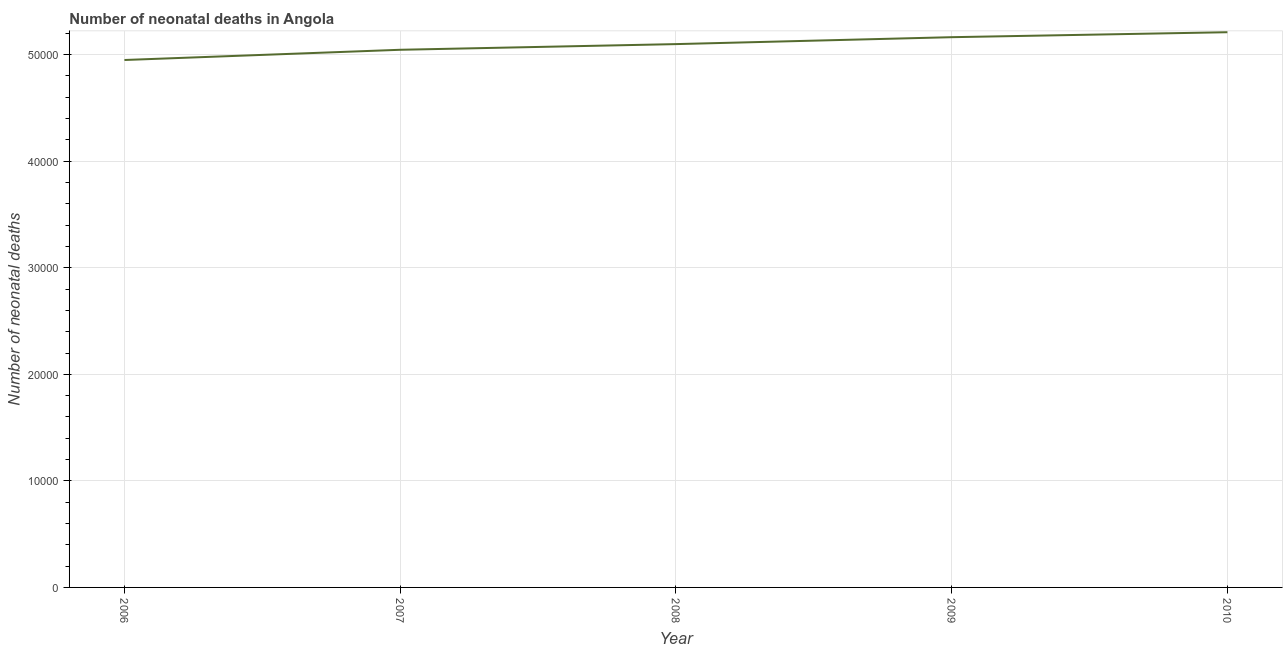What is the number of neonatal deaths in 2006?
Make the answer very short. 4.95e+04. Across all years, what is the maximum number of neonatal deaths?
Keep it short and to the point. 5.21e+04. Across all years, what is the minimum number of neonatal deaths?
Make the answer very short. 4.95e+04. In which year was the number of neonatal deaths minimum?
Your response must be concise. 2006. What is the sum of the number of neonatal deaths?
Your response must be concise. 2.55e+05. What is the difference between the number of neonatal deaths in 2006 and 2010?
Ensure brevity in your answer.  -2608. What is the average number of neonatal deaths per year?
Offer a terse response. 5.09e+04. What is the median number of neonatal deaths?
Provide a succinct answer. 5.10e+04. In how many years, is the number of neonatal deaths greater than 42000 ?
Your response must be concise. 5. Do a majority of the years between 2007 and 2008 (inclusive) have number of neonatal deaths greater than 40000 ?
Provide a succinct answer. Yes. What is the ratio of the number of neonatal deaths in 2006 to that in 2008?
Offer a terse response. 0.97. Is the difference between the number of neonatal deaths in 2006 and 2008 greater than the difference between any two years?
Give a very brief answer. No. What is the difference between the highest and the second highest number of neonatal deaths?
Offer a terse response. 467. What is the difference between the highest and the lowest number of neonatal deaths?
Offer a very short reply. 2608. Does the number of neonatal deaths monotonically increase over the years?
Offer a terse response. Yes. How many lines are there?
Offer a very short reply. 1. What is the difference between two consecutive major ticks on the Y-axis?
Make the answer very short. 10000. Are the values on the major ticks of Y-axis written in scientific E-notation?
Offer a very short reply. No. Does the graph contain grids?
Keep it short and to the point. Yes. What is the title of the graph?
Ensure brevity in your answer.  Number of neonatal deaths in Angola. What is the label or title of the X-axis?
Provide a succinct answer. Year. What is the label or title of the Y-axis?
Your response must be concise. Number of neonatal deaths. What is the Number of neonatal deaths of 2006?
Your answer should be very brief. 4.95e+04. What is the Number of neonatal deaths of 2007?
Your answer should be very brief. 5.05e+04. What is the Number of neonatal deaths in 2008?
Offer a very short reply. 5.10e+04. What is the Number of neonatal deaths in 2009?
Offer a terse response. 5.16e+04. What is the Number of neonatal deaths of 2010?
Offer a very short reply. 5.21e+04. What is the difference between the Number of neonatal deaths in 2006 and 2007?
Ensure brevity in your answer.  -959. What is the difference between the Number of neonatal deaths in 2006 and 2008?
Ensure brevity in your answer.  -1491. What is the difference between the Number of neonatal deaths in 2006 and 2009?
Keep it short and to the point. -2141. What is the difference between the Number of neonatal deaths in 2006 and 2010?
Ensure brevity in your answer.  -2608. What is the difference between the Number of neonatal deaths in 2007 and 2008?
Provide a succinct answer. -532. What is the difference between the Number of neonatal deaths in 2007 and 2009?
Offer a terse response. -1182. What is the difference between the Number of neonatal deaths in 2007 and 2010?
Your response must be concise. -1649. What is the difference between the Number of neonatal deaths in 2008 and 2009?
Ensure brevity in your answer.  -650. What is the difference between the Number of neonatal deaths in 2008 and 2010?
Your answer should be very brief. -1117. What is the difference between the Number of neonatal deaths in 2009 and 2010?
Your answer should be very brief. -467. What is the ratio of the Number of neonatal deaths in 2006 to that in 2007?
Provide a short and direct response. 0.98. What is the ratio of the Number of neonatal deaths in 2006 to that in 2008?
Provide a succinct answer. 0.97. What is the ratio of the Number of neonatal deaths in 2007 to that in 2010?
Give a very brief answer. 0.97. What is the ratio of the Number of neonatal deaths in 2008 to that in 2009?
Your answer should be compact. 0.99. What is the ratio of the Number of neonatal deaths in 2008 to that in 2010?
Ensure brevity in your answer.  0.98. What is the ratio of the Number of neonatal deaths in 2009 to that in 2010?
Offer a very short reply. 0.99. 